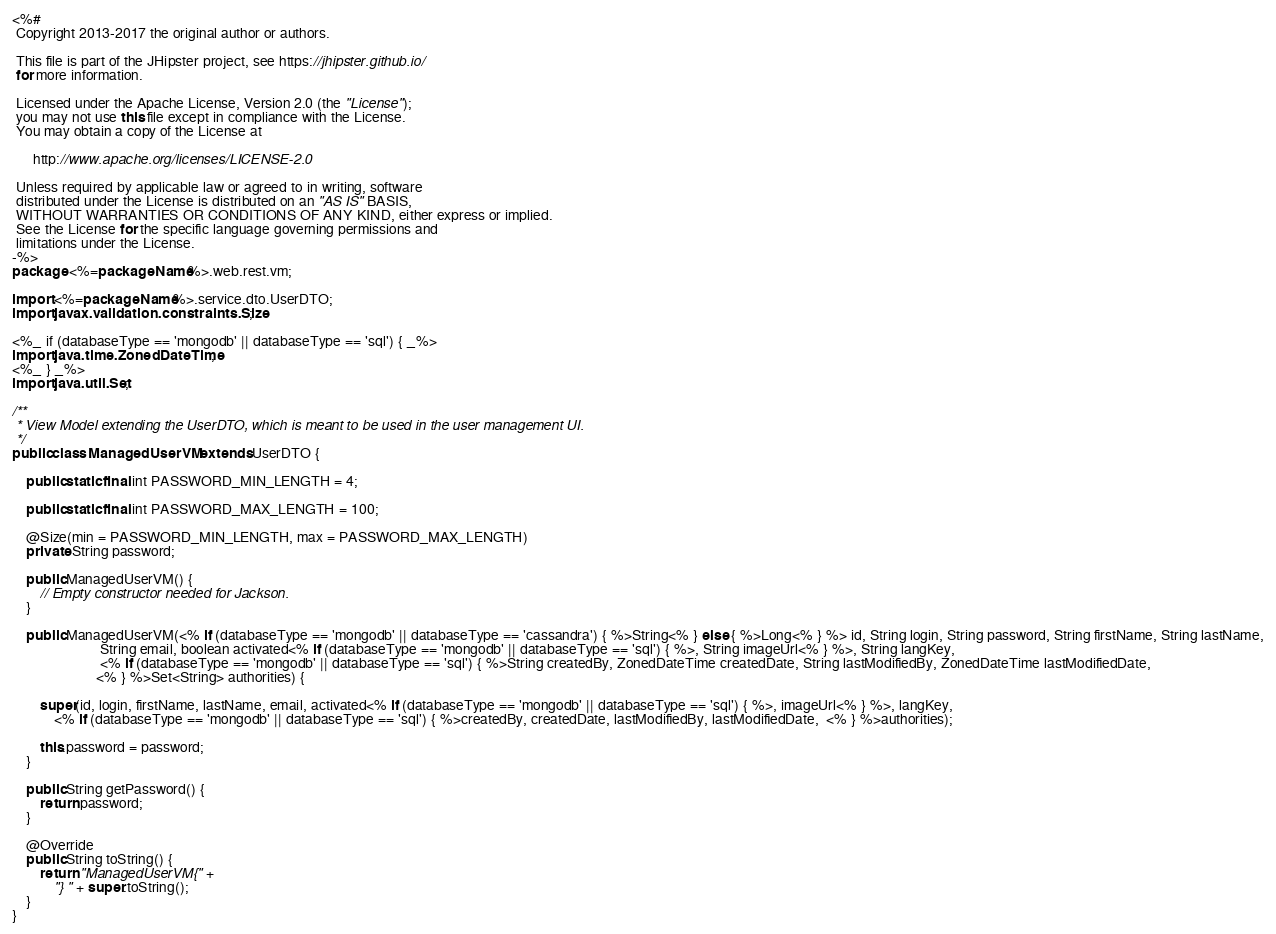Convert code to text. <code><loc_0><loc_0><loc_500><loc_500><_Java_><%#
 Copyright 2013-2017 the original author or authors.

 This file is part of the JHipster project, see https://jhipster.github.io/
 for more information.

 Licensed under the Apache License, Version 2.0 (the "License");
 you may not use this file except in compliance with the License.
 You may obtain a copy of the License at

      http://www.apache.org/licenses/LICENSE-2.0

 Unless required by applicable law or agreed to in writing, software
 distributed under the License is distributed on an "AS IS" BASIS,
 WITHOUT WARRANTIES OR CONDITIONS OF ANY KIND, either express or implied.
 See the License for the specific language governing permissions and
 limitations under the License.
-%>
package <%=packageName%>.web.rest.vm;

import <%=packageName%>.service.dto.UserDTO;
import javax.validation.constraints.Size;

<%_ if (databaseType == 'mongodb' || databaseType == 'sql') { _%>
import java.time.ZonedDateTime;
<%_ } _%>
import java.util.Set;

/**
 * View Model extending the UserDTO, which is meant to be used in the user management UI.
 */
public class ManagedUserVM extends UserDTO {

    public static final int PASSWORD_MIN_LENGTH = 4;

    public static final int PASSWORD_MAX_LENGTH = 100;

    @Size(min = PASSWORD_MIN_LENGTH, max = PASSWORD_MAX_LENGTH)
    private String password;

    public ManagedUserVM() {
        // Empty constructor needed for Jackson.
    }

    public ManagedUserVM(<% if (databaseType == 'mongodb' || databaseType == 'cassandra') { %>String<% } else { %>Long<% } %> id, String login, String password, String firstName, String lastName,
                         String email, boolean activated<% if (databaseType == 'mongodb' || databaseType == 'sql') { %>, String imageUrl<% } %>, String langKey,
                         <% if (databaseType == 'mongodb' || databaseType == 'sql') { %>String createdBy, ZonedDateTime createdDate, String lastModifiedBy, ZonedDateTime lastModifiedDate,
                        <% } %>Set<String> authorities) {

        super(id, login, firstName, lastName, email, activated<% if (databaseType == 'mongodb' || databaseType == 'sql') { %>, imageUrl<% } %>, langKey,
            <% if (databaseType == 'mongodb' || databaseType == 'sql') { %>createdBy, createdDate, lastModifiedBy, lastModifiedDate,  <% } %>authorities);

        this.password = password;
    }

    public String getPassword() {
        return password;
    }

    @Override
    public String toString() {
        return "ManagedUserVM{" +
            "} " + super.toString();
    }
}
</code> 